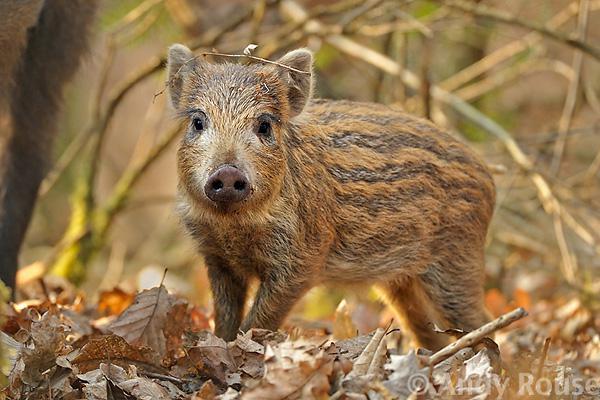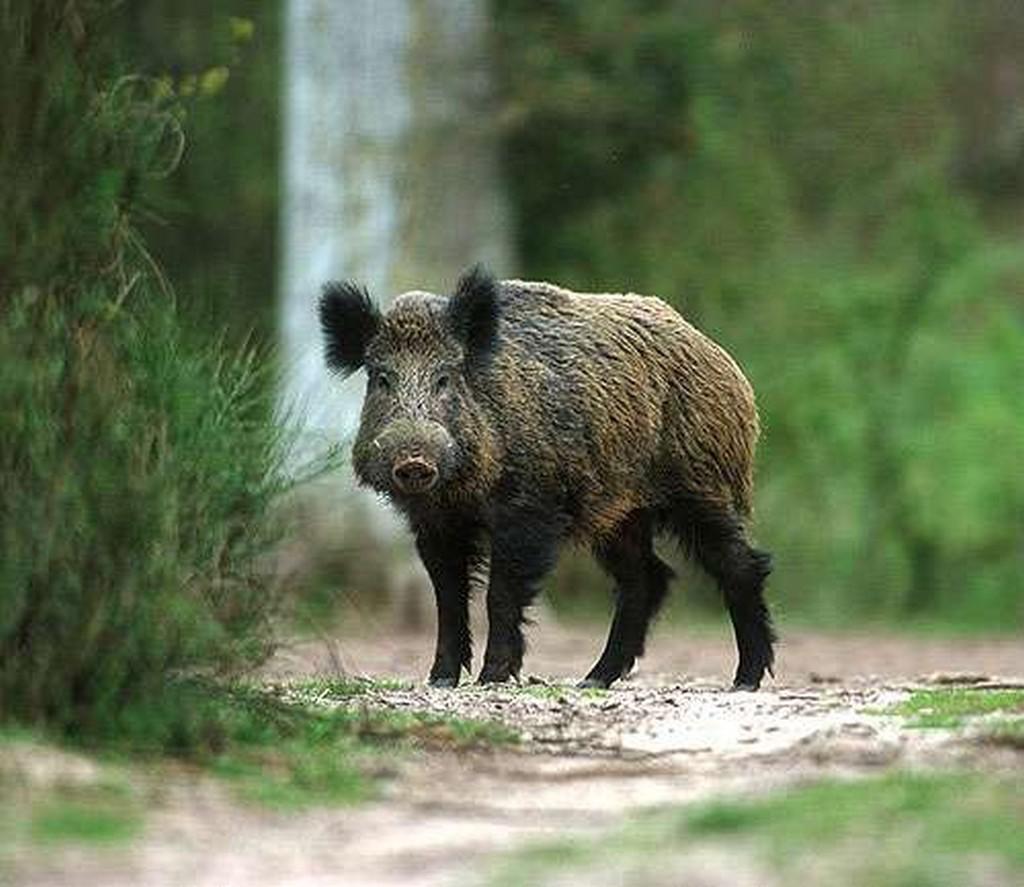The first image is the image on the left, the second image is the image on the right. Given the left and right images, does the statement "One image shows a single adult pig in profile, and the other image includes at least one adult wild pig with two smaller piglets." hold true? Answer yes or no. No. The first image is the image on the left, the second image is the image on the right. Analyze the images presented: Is the assertion "There are two hogs in total." valid? Answer yes or no. Yes. 